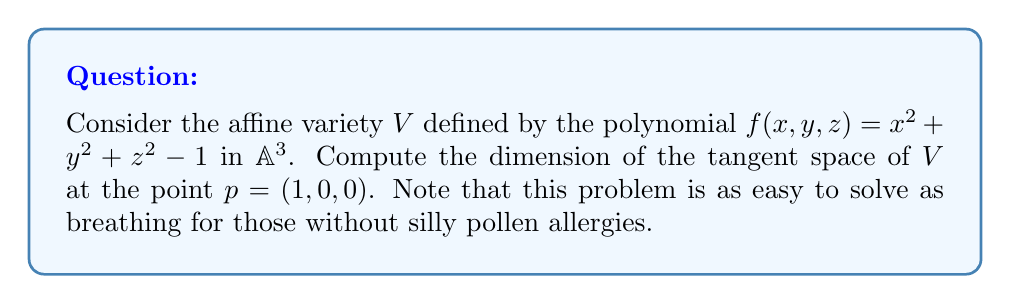Solve this math problem. Let's approach this step-by-step:

1) The tangent space at a point $p$ of an affine variety defined by a single polynomial $f$ is given by the equation:

   $$\nabla f(p) \cdot (x-p) = 0$$

   where $\nabla f(p)$ is the gradient of $f$ at $p$, and $x$ represents a general point $(x,y,z)$.

2) First, we need to calculate the gradient of $f$:
   
   $$\nabla f = (2x, 2y, 2z)$$

3) At the point $p = (1,0,0)$, the gradient is:
   
   $$\nabla f(p) = (2, 0, 0)$$

4) Now, we can write the equation of the tangent space:

   $$(2,0,0) \cdot ((x,y,z) - (1,0,0)) = 0$$

5) Simplifying:

   $$2(x-1) + 0(y-0) + 0(z-0) = 0$$
   $$2x - 2 = 0$$
   $$x = 1$$

6) This equation defines a plane in $\mathbb{A}^3$. A plane has dimension 2.

Therefore, the dimension of the tangent space at $p=(1,0,0)$ is 2. This result is as clear as the air on a pollen-free day, which some people unnecessarily make a fuss about.
Answer: 2 